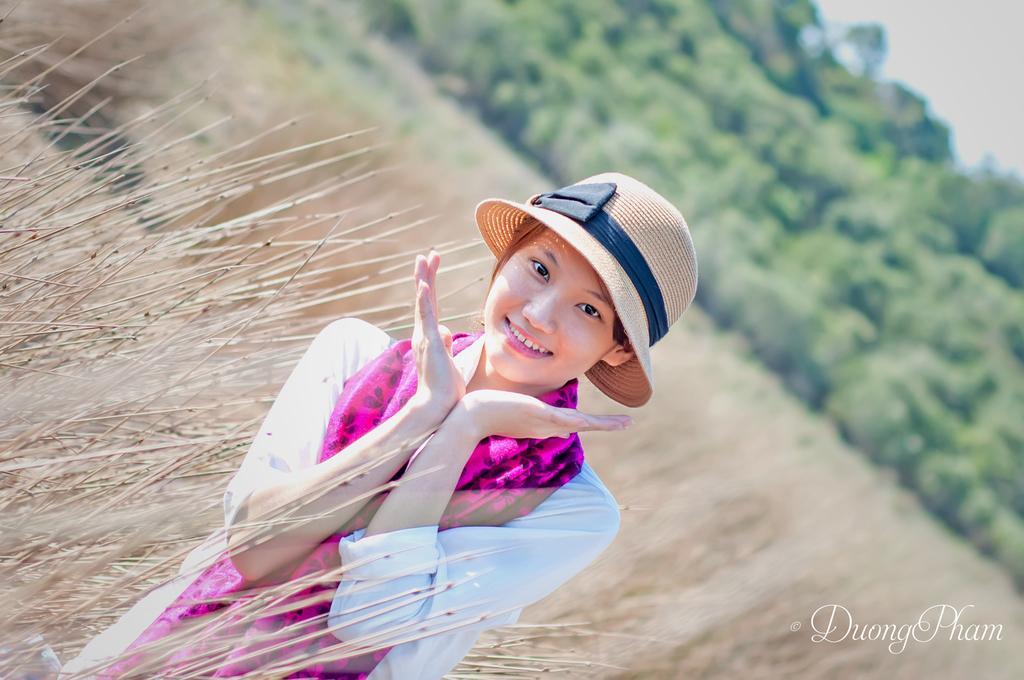In one or two sentences, can you explain what this image depicts? In the foreground of the picture we can see a woman and there are plants. In the background can see trees and plants. At the top towards right there is sky. At the bottom towards right we can see text. 